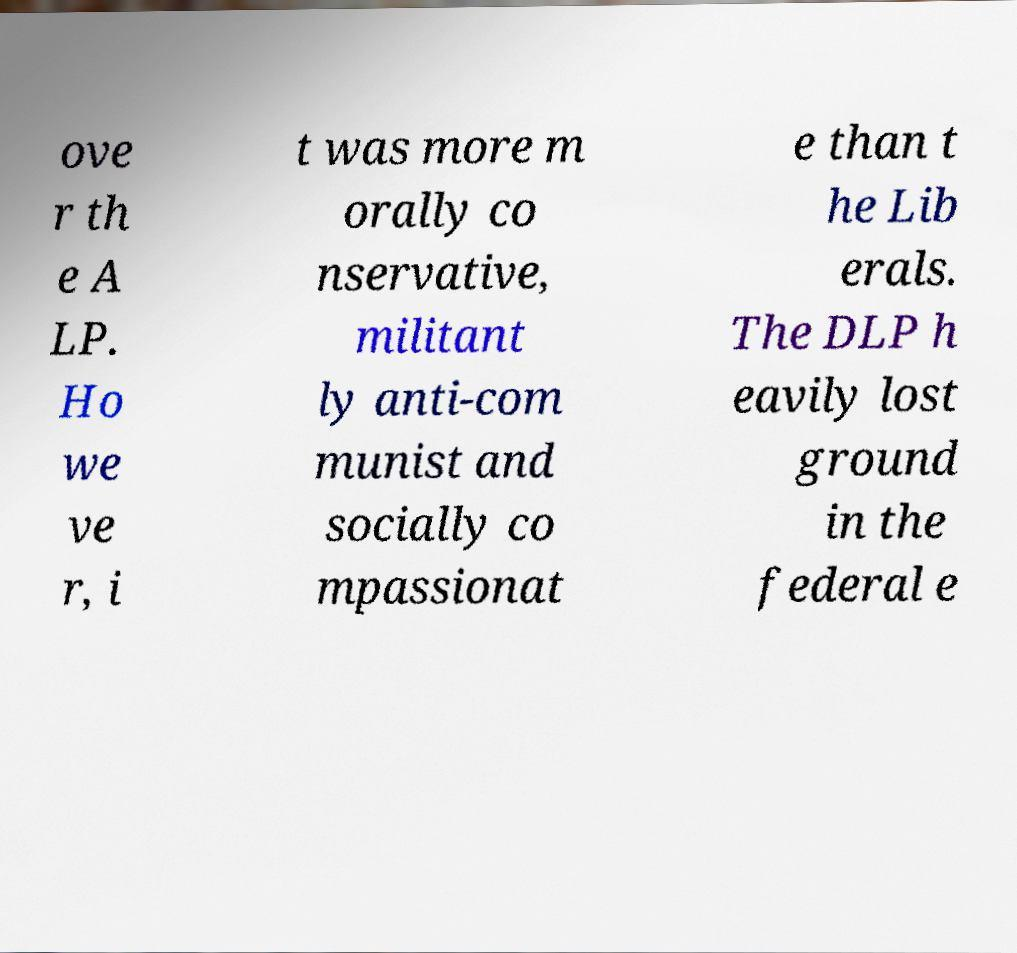I need the written content from this picture converted into text. Can you do that? ove r th e A LP. Ho we ve r, i t was more m orally co nservative, militant ly anti-com munist and socially co mpassionat e than t he Lib erals. The DLP h eavily lost ground in the federal e 